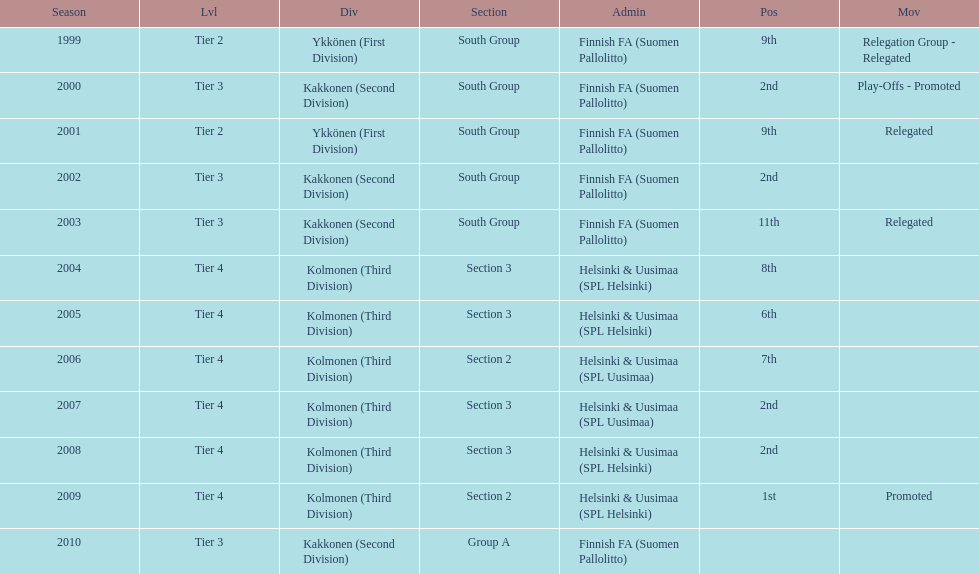What division were they in the most, section 3 or 2? 3. 